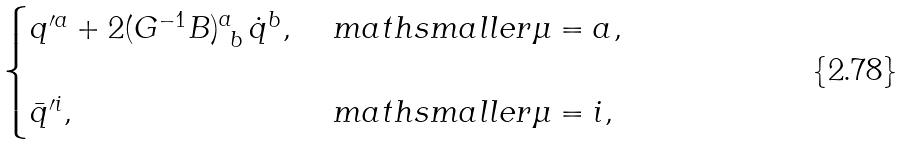<formula> <loc_0><loc_0><loc_500><loc_500>\begin{cases} q ^ { \prime a } + 2 ( G ^ { - 1 } B ) ^ { a } _ { \ b } \, \dot { q } ^ { b } , & { \ m a t h s m a l l e r { \mu = a } } , \\ & \\ \bar { q } ^ { \prime i } , & { \ m a t h s m a l l e r { \mu = i } } , \end{cases}</formula> 